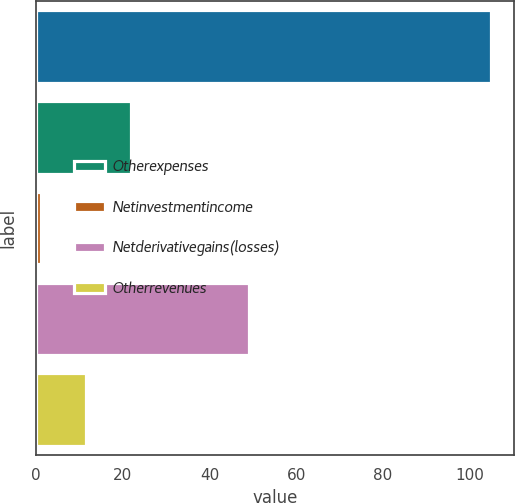Convert chart to OTSL. <chart><loc_0><loc_0><loc_500><loc_500><bar_chart><ecel><fcel>Otherexpenses<fcel>Netinvestmentincome<fcel>Netderivativegains(losses)<fcel>Otherrevenues<nl><fcel>105<fcel>21.8<fcel>1<fcel>49<fcel>11.4<nl></chart> 